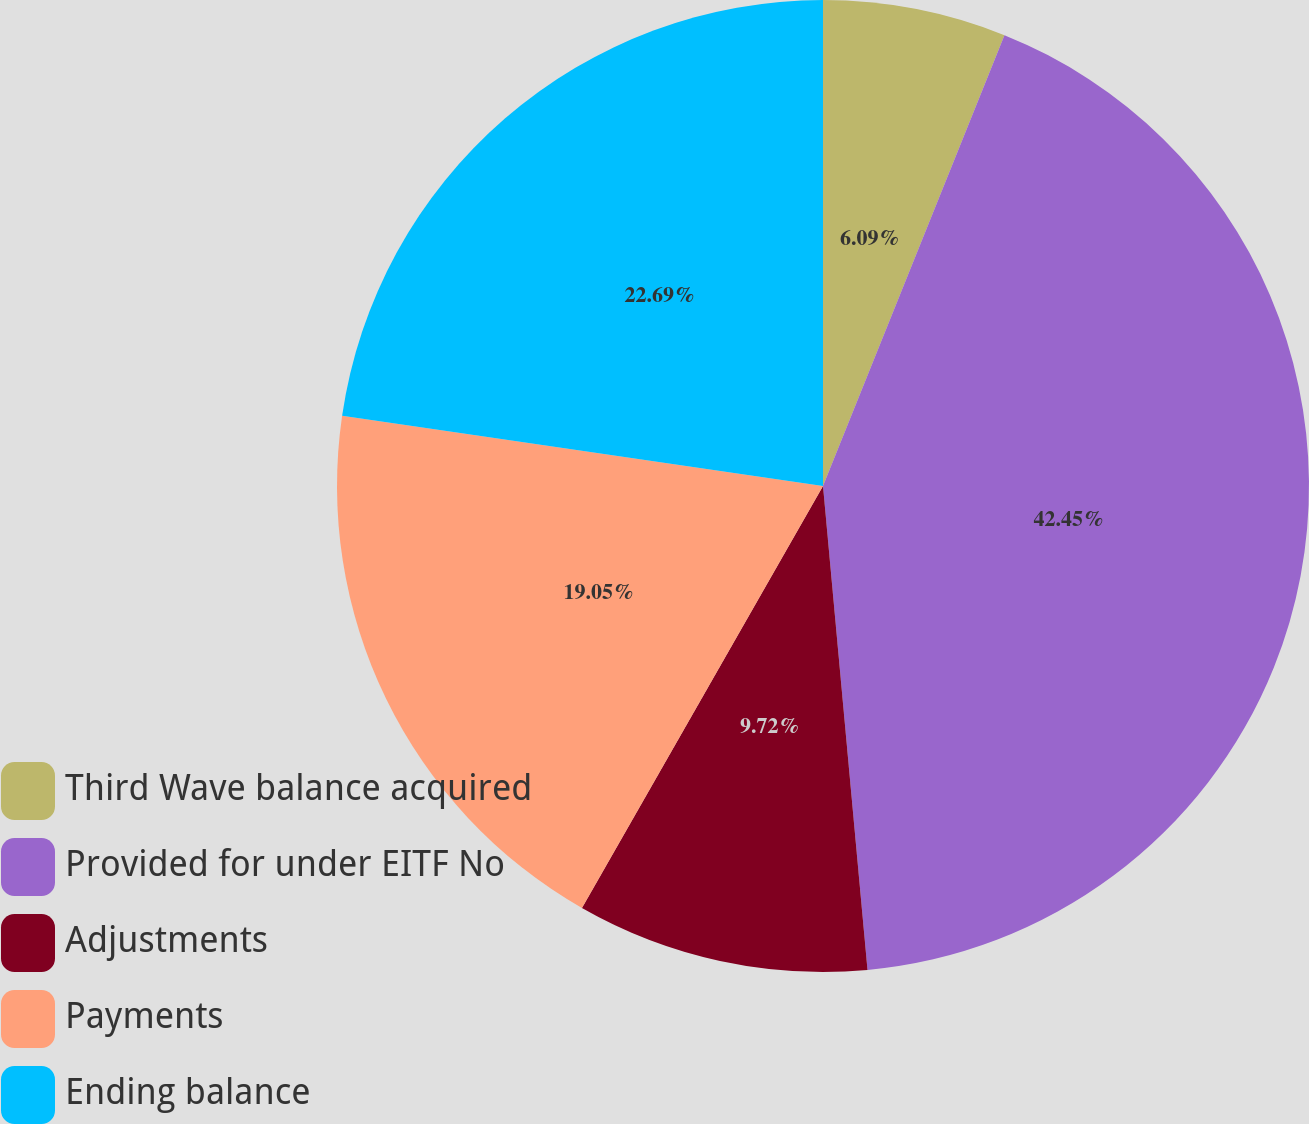Convert chart. <chart><loc_0><loc_0><loc_500><loc_500><pie_chart><fcel>Third Wave balance acquired<fcel>Provided for under EITF No<fcel>Adjustments<fcel>Payments<fcel>Ending balance<nl><fcel>6.09%<fcel>42.45%<fcel>9.72%<fcel>19.05%<fcel>22.69%<nl></chart> 